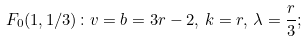Convert formula to latex. <formula><loc_0><loc_0><loc_500><loc_500>F _ { 0 } ( 1 , 1 / 3 ) \colon v = b = 3 r - 2 , \, k = r , \, \lambda = \frac { r } { 3 } ;</formula> 